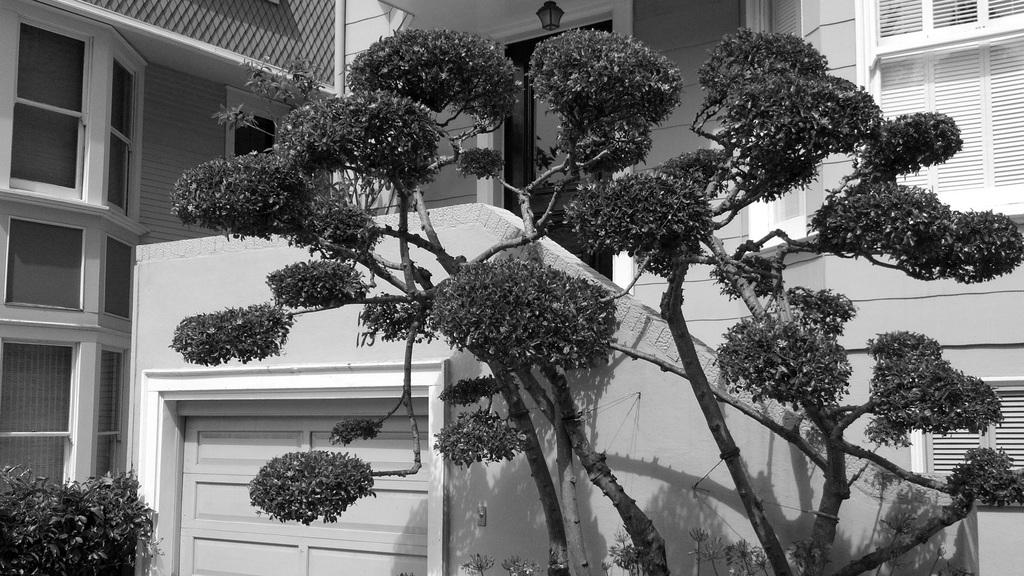What is located in front of the building in the image? There is a tree in front of the building. Where can you find a plant in the image? The plant is in the bottom left of the image. How many cars are parked under the tree in the image? There are no cars present in the image; it only features a tree in front of a building and a plant in the bottom left corner. 